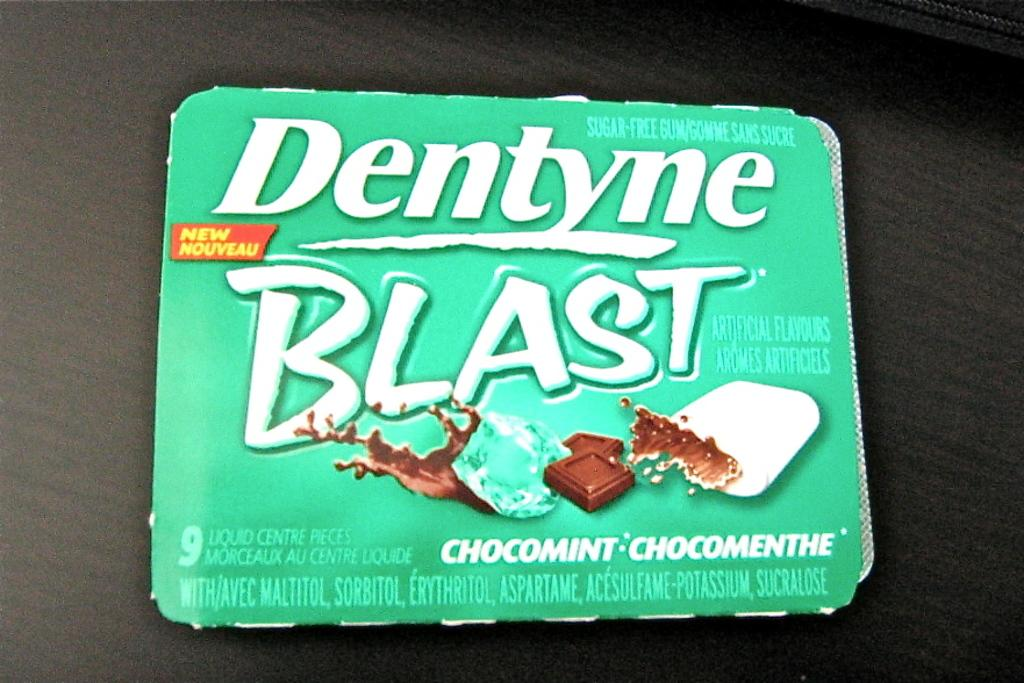What is present in the image that is not a solid object? There is a wrapper in the image. What can be seen on the wrapper? There is writing on the wrapper. What else is present on the wrapper? There is a label on the wrapper. How much is the beggar asking for in the image? There is no beggar present in the image. What type of structure is visible in the image? There is no structure visible in the image; it only features a wrapper with writing and a label. 